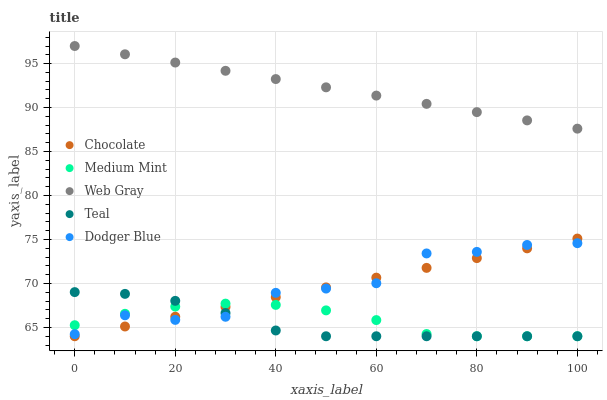Does Teal have the minimum area under the curve?
Answer yes or no. Yes. Does Web Gray have the maximum area under the curve?
Answer yes or no. Yes. Does Dodger Blue have the minimum area under the curve?
Answer yes or no. No. Does Dodger Blue have the maximum area under the curve?
Answer yes or no. No. Is Chocolate the smoothest?
Answer yes or no. Yes. Is Dodger Blue the roughest?
Answer yes or no. Yes. Is Web Gray the smoothest?
Answer yes or no. No. Is Web Gray the roughest?
Answer yes or no. No. Does Medium Mint have the lowest value?
Answer yes or no. Yes. Does Dodger Blue have the lowest value?
Answer yes or no. No. Does Web Gray have the highest value?
Answer yes or no. Yes. Does Dodger Blue have the highest value?
Answer yes or no. No. Is Dodger Blue less than Web Gray?
Answer yes or no. Yes. Is Web Gray greater than Teal?
Answer yes or no. Yes. Does Teal intersect Medium Mint?
Answer yes or no. Yes. Is Teal less than Medium Mint?
Answer yes or no. No. Is Teal greater than Medium Mint?
Answer yes or no. No. Does Dodger Blue intersect Web Gray?
Answer yes or no. No. 